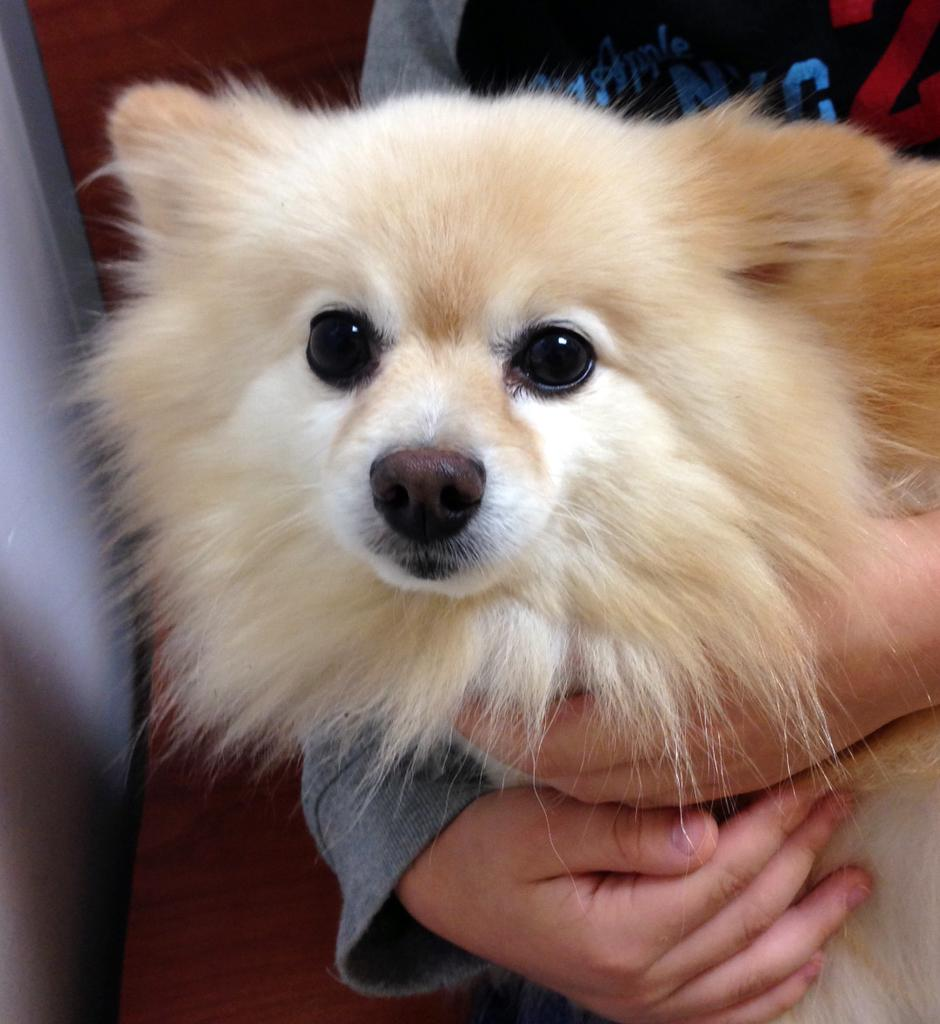What is the main subject of the image? There is a person in the image. What is the person holding in the image? The person is holding a white color dog. How is the dog being held by the person? The dog is being held with both hands. What else can be seen in the background of the image? There are other objects in the background of the image. What type of trousers is the person wearing in the image? The provided facts do not mention the type of trousers the person is wearing, so we cannot determine that information from the image. Is the dog feeling hot in the image? The provided facts do not mention the dog's temperature or any indication of heat, so we cannot determine if the dog is feeling hot from the image. 